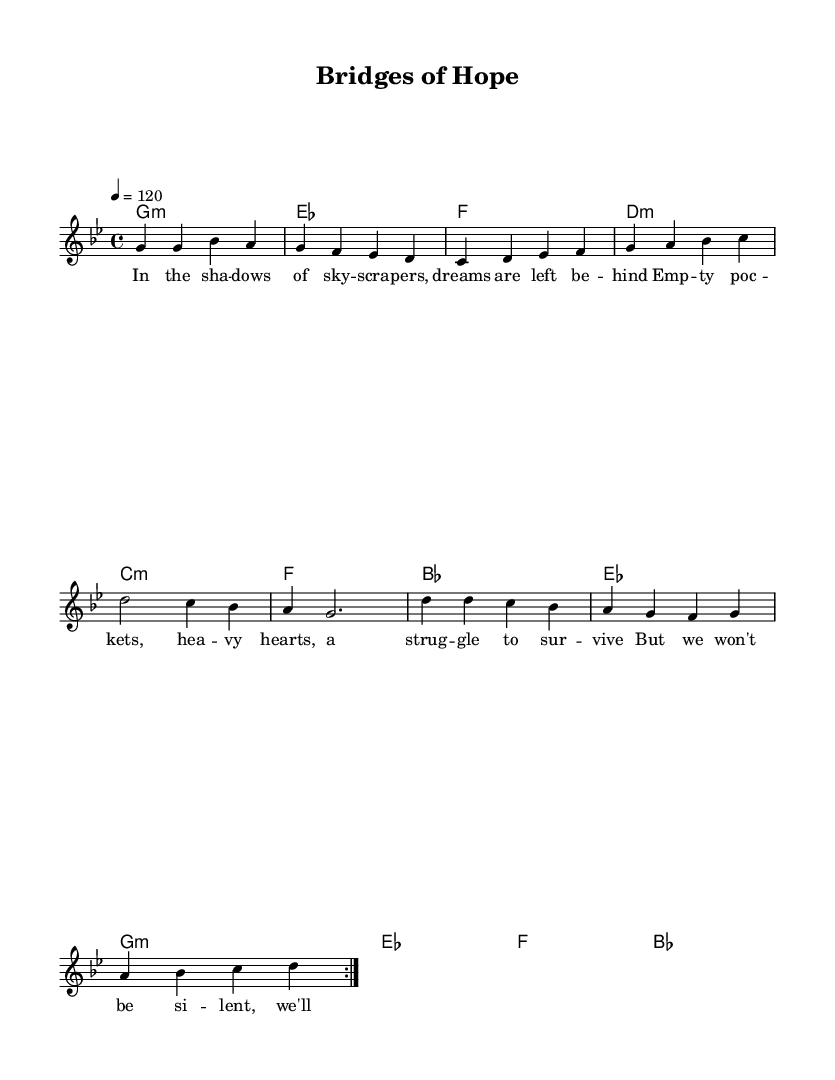What is the key signature of this music? The key signature is indicated at the beginning of the sheet music, which shows that there are two flats. This suggests that the music is in G minor.
Answer: G minor What is the time signature of this music? The time signature, located at the beginning of the music, indicates 4/4 time. This means there are four beats in each measure.
Answer: 4/4 What is the tempo marking for this piece? The tempo marking is given at the start as "4 = 120," indicating that there are 120 quarter-note beats per minute.
Answer: 120 What is the starting note of the melody? The melody begins on the note G, which is indicated by the first note in the melody line.
Answer: G How many sections are there in this song? Examining the structure of the lyrics, there is a verse, a pre-chorus, and a chorus, indicating three distinct sections.
Answer: Three What lyrical theme does the chorus address? The chorus conveys themes of unity and hope in overcoming divides, as indicated by the lyrics which discuss building bridges and standing side by side.
Answer: Unity and hope Which social issue is highlighted in the verse? The verse addresses social inequality and the struggles of individuals with empty pockets and heavy hearts, which suggests themes of economic disparity.
Answer: Economic disparity 